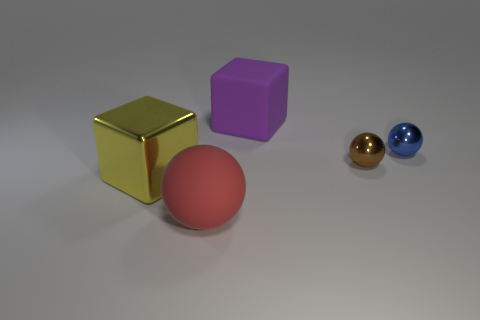Considering their colors, how might these objects be used in a color theory lesson? These objects could serve as practical examples in a color theory lesson to illustrate concepts such as hue, luminance, and saturation. For instance, the gold cube demonstrates a high saturation, while the purple cube and the spheres can be used to discuss hue variations and the effects of light on color perception. 